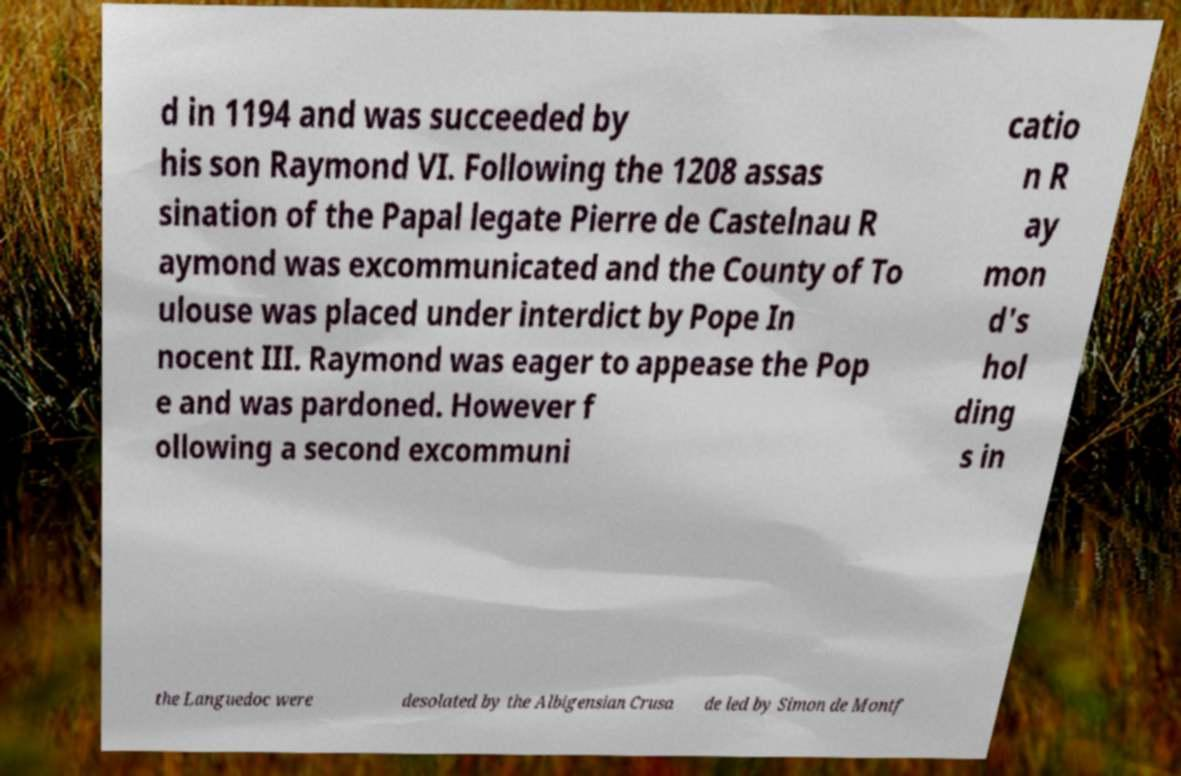What messages or text are displayed in this image? I need them in a readable, typed format. d in 1194 and was succeeded by his son Raymond VI. Following the 1208 assas sination of the Papal legate Pierre de Castelnau R aymond was excommunicated and the County of To ulouse was placed under interdict by Pope In nocent III. Raymond was eager to appease the Pop e and was pardoned. However f ollowing a second excommuni catio n R ay mon d's hol ding s in the Languedoc were desolated by the Albigensian Crusa de led by Simon de Montf 